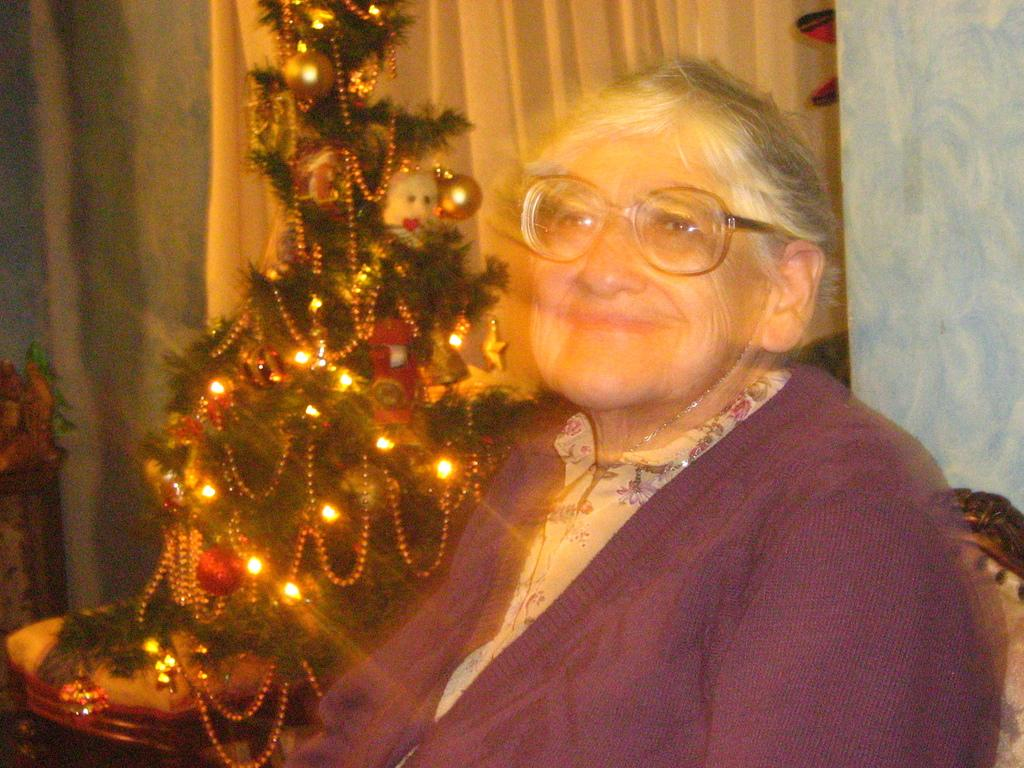Who is present in the image? There is a woman in the image. What is the woman wearing? The woman is wearing glasses. What is the woman doing in the image? The woman is sitting and smiling. What can be seen in the background of the image? There is a curtain, a wall, a chair, and a Christmas tree with lights in the background of the image. What type of squirrel can be seen climbing the Christmas tree in the image? There is no squirrel present in the image, and therefore no such activity can be observed. 